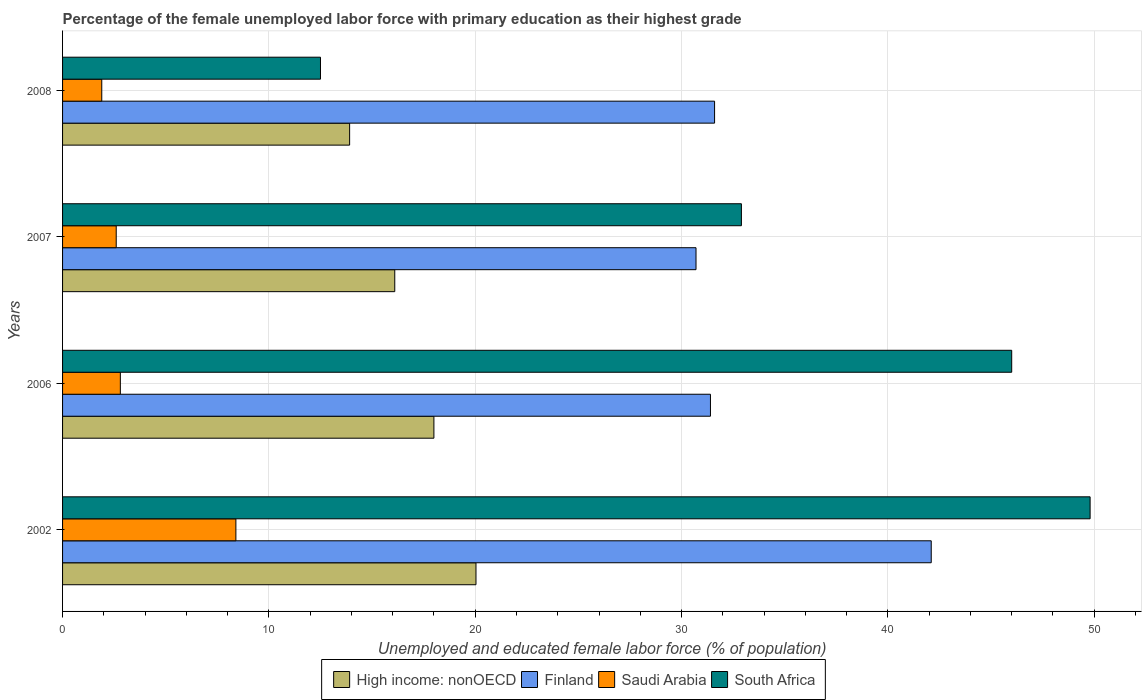How many groups of bars are there?
Ensure brevity in your answer.  4. What is the percentage of the unemployed female labor force with primary education in High income: nonOECD in 2008?
Offer a very short reply. 13.91. Across all years, what is the maximum percentage of the unemployed female labor force with primary education in South Africa?
Ensure brevity in your answer.  49.8. Across all years, what is the minimum percentage of the unemployed female labor force with primary education in South Africa?
Offer a terse response. 12.5. In which year was the percentage of the unemployed female labor force with primary education in South Africa minimum?
Your answer should be compact. 2008. What is the total percentage of the unemployed female labor force with primary education in Saudi Arabia in the graph?
Give a very brief answer. 15.7. What is the difference between the percentage of the unemployed female labor force with primary education in Saudi Arabia in 2006 and that in 2008?
Make the answer very short. 0.9. What is the difference between the percentage of the unemployed female labor force with primary education in Saudi Arabia in 2008 and the percentage of the unemployed female labor force with primary education in High income: nonOECD in 2007?
Your answer should be very brief. -14.2. What is the average percentage of the unemployed female labor force with primary education in Saudi Arabia per year?
Ensure brevity in your answer.  3.92. In the year 2007, what is the difference between the percentage of the unemployed female labor force with primary education in South Africa and percentage of the unemployed female labor force with primary education in Finland?
Offer a very short reply. 2.2. What is the ratio of the percentage of the unemployed female labor force with primary education in High income: nonOECD in 2002 to that in 2007?
Give a very brief answer. 1.24. Is the difference between the percentage of the unemployed female labor force with primary education in South Africa in 2006 and 2008 greater than the difference between the percentage of the unemployed female labor force with primary education in Finland in 2006 and 2008?
Make the answer very short. Yes. What is the difference between the highest and the second highest percentage of the unemployed female labor force with primary education in South Africa?
Offer a terse response. 3.8. What is the difference between the highest and the lowest percentage of the unemployed female labor force with primary education in South Africa?
Offer a very short reply. 37.3. In how many years, is the percentage of the unemployed female labor force with primary education in South Africa greater than the average percentage of the unemployed female labor force with primary education in South Africa taken over all years?
Provide a succinct answer. 2. Is it the case that in every year, the sum of the percentage of the unemployed female labor force with primary education in South Africa and percentage of the unemployed female labor force with primary education in Finland is greater than the sum of percentage of the unemployed female labor force with primary education in Saudi Arabia and percentage of the unemployed female labor force with primary education in High income: nonOECD?
Your answer should be compact. No. What does the 4th bar from the top in 2006 represents?
Give a very brief answer. High income: nonOECD. What does the 1st bar from the bottom in 2002 represents?
Ensure brevity in your answer.  High income: nonOECD. Is it the case that in every year, the sum of the percentage of the unemployed female labor force with primary education in High income: nonOECD and percentage of the unemployed female labor force with primary education in Saudi Arabia is greater than the percentage of the unemployed female labor force with primary education in Finland?
Keep it short and to the point. No. How many years are there in the graph?
Offer a very short reply. 4. What is the difference between two consecutive major ticks on the X-axis?
Offer a terse response. 10. Does the graph contain any zero values?
Your answer should be compact. No. What is the title of the graph?
Offer a very short reply. Percentage of the female unemployed labor force with primary education as their highest grade. Does "Canada" appear as one of the legend labels in the graph?
Your answer should be compact. No. What is the label or title of the X-axis?
Ensure brevity in your answer.  Unemployed and educated female labor force (% of population). What is the Unemployed and educated female labor force (% of population) of High income: nonOECD in 2002?
Give a very brief answer. 20.04. What is the Unemployed and educated female labor force (% of population) of Finland in 2002?
Provide a succinct answer. 42.1. What is the Unemployed and educated female labor force (% of population) in Saudi Arabia in 2002?
Give a very brief answer. 8.4. What is the Unemployed and educated female labor force (% of population) in South Africa in 2002?
Give a very brief answer. 49.8. What is the Unemployed and educated female labor force (% of population) in High income: nonOECD in 2006?
Offer a very short reply. 18. What is the Unemployed and educated female labor force (% of population) of Finland in 2006?
Offer a terse response. 31.4. What is the Unemployed and educated female labor force (% of population) in Saudi Arabia in 2006?
Offer a very short reply. 2.8. What is the Unemployed and educated female labor force (% of population) in South Africa in 2006?
Offer a terse response. 46. What is the Unemployed and educated female labor force (% of population) in High income: nonOECD in 2007?
Offer a terse response. 16.1. What is the Unemployed and educated female labor force (% of population) of Finland in 2007?
Offer a terse response. 30.7. What is the Unemployed and educated female labor force (% of population) of Saudi Arabia in 2007?
Offer a very short reply. 2.6. What is the Unemployed and educated female labor force (% of population) of South Africa in 2007?
Your answer should be very brief. 32.9. What is the Unemployed and educated female labor force (% of population) of High income: nonOECD in 2008?
Keep it short and to the point. 13.91. What is the Unemployed and educated female labor force (% of population) of Finland in 2008?
Your response must be concise. 31.6. What is the Unemployed and educated female labor force (% of population) of Saudi Arabia in 2008?
Make the answer very short. 1.9. Across all years, what is the maximum Unemployed and educated female labor force (% of population) of High income: nonOECD?
Give a very brief answer. 20.04. Across all years, what is the maximum Unemployed and educated female labor force (% of population) of Finland?
Give a very brief answer. 42.1. Across all years, what is the maximum Unemployed and educated female labor force (% of population) of Saudi Arabia?
Ensure brevity in your answer.  8.4. Across all years, what is the maximum Unemployed and educated female labor force (% of population) in South Africa?
Give a very brief answer. 49.8. Across all years, what is the minimum Unemployed and educated female labor force (% of population) of High income: nonOECD?
Your response must be concise. 13.91. Across all years, what is the minimum Unemployed and educated female labor force (% of population) in Finland?
Your answer should be compact. 30.7. Across all years, what is the minimum Unemployed and educated female labor force (% of population) of Saudi Arabia?
Offer a terse response. 1.9. What is the total Unemployed and educated female labor force (% of population) of High income: nonOECD in the graph?
Your answer should be compact. 68.05. What is the total Unemployed and educated female labor force (% of population) in Finland in the graph?
Your answer should be very brief. 135.8. What is the total Unemployed and educated female labor force (% of population) in South Africa in the graph?
Ensure brevity in your answer.  141.2. What is the difference between the Unemployed and educated female labor force (% of population) in High income: nonOECD in 2002 and that in 2006?
Your answer should be very brief. 2.04. What is the difference between the Unemployed and educated female labor force (% of population) in Finland in 2002 and that in 2006?
Ensure brevity in your answer.  10.7. What is the difference between the Unemployed and educated female labor force (% of population) of Saudi Arabia in 2002 and that in 2006?
Offer a very short reply. 5.6. What is the difference between the Unemployed and educated female labor force (% of population) in High income: nonOECD in 2002 and that in 2007?
Offer a terse response. 3.94. What is the difference between the Unemployed and educated female labor force (% of population) of Finland in 2002 and that in 2007?
Offer a terse response. 11.4. What is the difference between the Unemployed and educated female labor force (% of population) in High income: nonOECD in 2002 and that in 2008?
Keep it short and to the point. 6.12. What is the difference between the Unemployed and educated female labor force (% of population) of Saudi Arabia in 2002 and that in 2008?
Keep it short and to the point. 6.5. What is the difference between the Unemployed and educated female labor force (% of population) in South Africa in 2002 and that in 2008?
Provide a succinct answer. 37.3. What is the difference between the Unemployed and educated female labor force (% of population) in High income: nonOECD in 2006 and that in 2007?
Your response must be concise. 1.9. What is the difference between the Unemployed and educated female labor force (% of population) in Saudi Arabia in 2006 and that in 2007?
Offer a terse response. 0.2. What is the difference between the Unemployed and educated female labor force (% of population) in South Africa in 2006 and that in 2007?
Provide a succinct answer. 13.1. What is the difference between the Unemployed and educated female labor force (% of population) of High income: nonOECD in 2006 and that in 2008?
Offer a very short reply. 4.09. What is the difference between the Unemployed and educated female labor force (% of population) of Finland in 2006 and that in 2008?
Ensure brevity in your answer.  -0.2. What is the difference between the Unemployed and educated female labor force (% of population) in Saudi Arabia in 2006 and that in 2008?
Your answer should be very brief. 0.9. What is the difference between the Unemployed and educated female labor force (% of population) of South Africa in 2006 and that in 2008?
Offer a terse response. 33.5. What is the difference between the Unemployed and educated female labor force (% of population) in High income: nonOECD in 2007 and that in 2008?
Offer a very short reply. 2.19. What is the difference between the Unemployed and educated female labor force (% of population) of South Africa in 2007 and that in 2008?
Provide a short and direct response. 20.4. What is the difference between the Unemployed and educated female labor force (% of population) in High income: nonOECD in 2002 and the Unemployed and educated female labor force (% of population) in Finland in 2006?
Provide a short and direct response. -11.36. What is the difference between the Unemployed and educated female labor force (% of population) of High income: nonOECD in 2002 and the Unemployed and educated female labor force (% of population) of Saudi Arabia in 2006?
Give a very brief answer. 17.24. What is the difference between the Unemployed and educated female labor force (% of population) in High income: nonOECD in 2002 and the Unemployed and educated female labor force (% of population) in South Africa in 2006?
Offer a very short reply. -25.96. What is the difference between the Unemployed and educated female labor force (% of population) in Finland in 2002 and the Unemployed and educated female labor force (% of population) in Saudi Arabia in 2006?
Ensure brevity in your answer.  39.3. What is the difference between the Unemployed and educated female labor force (% of population) of Finland in 2002 and the Unemployed and educated female labor force (% of population) of South Africa in 2006?
Your answer should be compact. -3.9. What is the difference between the Unemployed and educated female labor force (% of population) in Saudi Arabia in 2002 and the Unemployed and educated female labor force (% of population) in South Africa in 2006?
Your response must be concise. -37.6. What is the difference between the Unemployed and educated female labor force (% of population) in High income: nonOECD in 2002 and the Unemployed and educated female labor force (% of population) in Finland in 2007?
Your response must be concise. -10.66. What is the difference between the Unemployed and educated female labor force (% of population) in High income: nonOECD in 2002 and the Unemployed and educated female labor force (% of population) in Saudi Arabia in 2007?
Offer a very short reply. 17.44. What is the difference between the Unemployed and educated female labor force (% of population) of High income: nonOECD in 2002 and the Unemployed and educated female labor force (% of population) of South Africa in 2007?
Keep it short and to the point. -12.86. What is the difference between the Unemployed and educated female labor force (% of population) in Finland in 2002 and the Unemployed and educated female labor force (% of population) in Saudi Arabia in 2007?
Keep it short and to the point. 39.5. What is the difference between the Unemployed and educated female labor force (% of population) of Finland in 2002 and the Unemployed and educated female labor force (% of population) of South Africa in 2007?
Offer a terse response. 9.2. What is the difference between the Unemployed and educated female labor force (% of population) of Saudi Arabia in 2002 and the Unemployed and educated female labor force (% of population) of South Africa in 2007?
Your answer should be compact. -24.5. What is the difference between the Unemployed and educated female labor force (% of population) in High income: nonOECD in 2002 and the Unemployed and educated female labor force (% of population) in Finland in 2008?
Ensure brevity in your answer.  -11.56. What is the difference between the Unemployed and educated female labor force (% of population) of High income: nonOECD in 2002 and the Unemployed and educated female labor force (% of population) of Saudi Arabia in 2008?
Give a very brief answer. 18.14. What is the difference between the Unemployed and educated female labor force (% of population) in High income: nonOECD in 2002 and the Unemployed and educated female labor force (% of population) in South Africa in 2008?
Your response must be concise. 7.54. What is the difference between the Unemployed and educated female labor force (% of population) in Finland in 2002 and the Unemployed and educated female labor force (% of population) in Saudi Arabia in 2008?
Make the answer very short. 40.2. What is the difference between the Unemployed and educated female labor force (% of population) of Finland in 2002 and the Unemployed and educated female labor force (% of population) of South Africa in 2008?
Give a very brief answer. 29.6. What is the difference between the Unemployed and educated female labor force (% of population) in High income: nonOECD in 2006 and the Unemployed and educated female labor force (% of population) in Finland in 2007?
Ensure brevity in your answer.  -12.7. What is the difference between the Unemployed and educated female labor force (% of population) of High income: nonOECD in 2006 and the Unemployed and educated female labor force (% of population) of Saudi Arabia in 2007?
Keep it short and to the point. 15.4. What is the difference between the Unemployed and educated female labor force (% of population) in High income: nonOECD in 2006 and the Unemployed and educated female labor force (% of population) in South Africa in 2007?
Make the answer very short. -14.9. What is the difference between the Unemployed and educated female labor force (% of population) of Finland in 2006 and the Unemployed and educated female labor force (% of population) of Saudi Arabia in 2007?
Your answer should be compact. 28.8. What is the difference between the Unemployed and educated female labor force (% of population) of Saudi Arabia in 2006 and the Unemployed and educated female labor force (% of population) of South Africa in 2007?
Your answer should be compact. -30.1. What is the difference between the Unemployed and educated female labor force (% of population) in High income: nonOECD in 2006 and the Unemployed and educated female labor force (% of population) in Finland in 2008?
Your answer should be very brief. -13.6. What is the difference between the Unemployed and educated female labor force (% of population) in High income: nonOECD in 2006 and the Unemployed and educated female labor force (% of population) in Saudi Arabia in 2008?
Offer a very short reply. 16.1. What is the difference between the Unemployed and educated female labor force (% of population) of High income: nonOECD in 2006 and the Unemployed and educated female labor force (% of population) of South Africa in 2008?
Your answer should be compact. 5.5. What is the difference between the Unemployed and educated female labor force (% of population) in Finland in 2006 and the Unemployed and educated female labor force (% of population) in Saudi Arabia in 2008?
Offer a very short reply. 29.5. What is the difference between the Unemployed and educated female labor force (% of population) of Finland in 2006 and the Unemployed and educated female labor force (% of population) of South Africa in 2008?
Keep it short and to the point. 18.9. What is the difference between the Unemployed and educated female labor force (% of population) in Saudi Arabia in 2006 and the Unemployed and educated female labor force (% of population) in South Africa in 2008?
Offer a very short reply. -9.7. What is the difference between the Unemployed and educated female labor force (% of population) in High income: nonOECD in 2007 and the Unemployed and educated female labor force (% of population) in Finland in 2008?
Give a very brief answer. -15.5. What is the difference between the Unemployed and educated female labor force (% of population) of High income: nonOECD in 2007 and the Unemployed and educated female labor force (% of population) of Saudi Arabia in 2008?
Ensure brevity in your answer.  14.2. What is the difference between the Unemployed and educated female labor force (% of population) of High income: nonOECD in 2007 and the Unemployed and educated female labor force (% of population) of South Africa in 2008?
Provide a succinct answer. 3.6. What is the difference between the Unemployed and educated female labor force (% of population) in Finland in 2007 and the Unemployed and educated female labor force (% of population) in Saudi Arabia in 2008?
Your response must be concise. 28.8. What is the average Unemployed and educated female labor force (% of population) in High income: nonOECD per year?
Give a very brief answer. 17.01. What is the average Unemployed and educated female labor force (% of population) of Finland per year?
Your answer should be very brief. 33.95. What is the average Unemployed and educated female labor force (% of population) of Saudi Arabia per year?
Your answer should be compact. 3.92. What is the average Unemployed and educated female labor force (% of population) in South Africa per year?
Offer a terse response. 35.3. In the year 2002, what is the difference between the Unemployed and educated female labor force (% of population) in High income: nonOECD and Unemployed and educated female labor force (% of population) in Finland?
Your answer should be very brief. -22.06. In the year 2002, what is the difference between the Unemployed and educated female labor force (% of population) of High income: nonOECD and Unemployed and educated female labor force (% of population) of Saudi Arabia?
Offer a terse response. 11.64. In the year 2002, what is the difference between the Unemployed and educated female labor force (% of population) in High income: nonOECD and Unemployed and educated female labor force (% of population) in South Africa?
Offer a very short reply. -29.76. In the year 2002, what is the difference between the Unemployed and educated female labor force (% of population) of Finland and Unemployed and educated female labor force (% of population) of Saudi Arabia?
Your answer should be compact. 33.7. In the year 2002, what is the difference between the Unemployed and educated female labor force (% of population) in Saudi Arabia and Unemployed and educated female labor force (% of population) in South Africa?
Make the answer very short. -41.4. In the year 2006, what is the difference between the Unemployed and educated female labor force (% of population) in High income: nonOECD and Unemployed and educated female labor force (% of population) in Finland?
Your answer should be compact. -13.4. In the year 2006, what is the difference between the Unemployed and educated female labor force (% of population) in High income: nonOECD and Unemployed and educated female labor force (% of population) in Saudi Arabia?
Your answer should be very brief. 15.2. In the year 2006, what is the difference between the Unemployed and educated female labor force (% of population) of High income: nonOECD and Unemployed and educated female labor force (% of population) of South Africa?
Ensure brevity in your answer.  -28. In the year 2006, what is the difference between the Unemployed and educated female labor force (% of population) in Finland and Unemployed and educated female labor force (% of population) in Saudi Arabia?
Offer a very short reply. 28.6. In the year 2006, what is the difference between the Unemployed and educated female labor force (% of population) in Finland and Unemployed and educated female labor force (% of population) in South Africa?
Keep it short and to the point. -14.6. In the year 2006, what is the difference between the Unemployed and educated female labor force (% of population) in Saudi Arabia and Unemployed and educated female labor force (% of population) in South Africa?
Your response must be concise. -43.2. In the year 2007, what is the difference between the Unemployed and educated female labor force (% of population) in High income: nonOECD and Unemployed and educated female labor force (% of population) in Finland?
Offer a very short reply. -14.6. In the year 2007, what is the difference between the Unemployed and educated female labor force (% of population) in High income: nonOECD and Unemployed and educated female labor force (% of population) in Saudi Arabia?
Offer a terse response. 13.5. In the year 2007, what is the difference between the Unemployed and educated female labor force (% of population) in High income: nonOECD and Unemployed and educated female labor force (% of population) in South Africa?
Make the answer very short. -16.8. In the year 2007, what is the difference between the Unemployed and educated female labor force (% of population) of Finland and Unemployed and educated female labor force (% of population) of Saudi Arabia?
Offer a very short reply. 28.1. In the year 2007, what is the difference between the Unemployed and educated female labor force (% of population) of Finland and Unemployed and educated female labor force (% of population) of South Africa?
Ensure brevity in your answer.  -2.2. In the year 2007, what is the difference between the Unemployed and educated female labor force (% of population) of Saudi Arabia and Unemployed and educated female labor force (% of population) of South Africa?
Ensure brevity in your answer.  -30.3. In the year 2008, what is the difference between the Unemployed and educated female labor force (% of population) in High income: nonOECD and Unemployed and educated female labor force (% of population) in Finland?
Your response must be concise. -17.69. In the year 2008, what is the difference between the Unemployed and educated female labor force (% of population) in High income: nonOECD and Unemployed and educated female labor force (% of population) in Saudi Arabia?
Your answer should be compact. 12.01. In the year 2008, what is the difference between the Unemployed and educated female labor force (% of population) in High income: nonOECD and Unemployed and educated female labor force (% of population) in South Africa?
Keep it short and to the point. 1.41. In the year 2008, what is the difference between the Unemployed and educated female labor force (% of population) of Finland and Unemployed and educated female labor force (% of population) of Saudi Arabia?
Make the answer very short. 29.7. What is the ratio of the Unemployed and educated female labor force (% of population) in High income: nonOECD in 2002 to that in 2006?
Give a very brief answer. 1.11. What is the ratio of the Unemployed and educated female labor force (% of population) of Finland in 2002 to that in 2006?
Your response must be concise. 1.34. What is the ratio of the Unemployed and educated female labor force (% of population) of South Africa in 2002 to that in 2006?
Offer a very short reply. 1.08. What is the ratio of the Unemployed and educated female labor force (% of population) in High income: nonOECD in 2002 to that in 2007?
Make the answer very short. 1.24. What is the ratio of the Unemployed and educated female labor force (% of population) in Finland in 2002 to that in 2007?
Offer a terse response. 1.37. What is the ratio of the Unemployed and educated female labor force (% of population) in Saudi Arabia in 2002 to that in 2007?
Your response must be concise. 3.23. What is the ratio of the Unemployed and educated female labor force (% of population) of South Africa in 2002 to that in 2007?
Provide a succinct answer. 1.51. What is the ratio of the Unemployed and educated female labor force (% of population) of High income: nonOECD in 2002 to that in 2008?
Offer a terse response. 1.44. What is the ratio of the Unemployed and educated female labor force (% of population) of Finland in 2002 to that in 2008?
Make the answer very short. 1.33. What is the ratio of the Unemployed and educated female labor force (% of population) of Saudi Arabia in 2002 to that in 2008?
Provide a succinct answer. 4.42. What is the ratio of the Unemployed and educated female labor force (% of population) of South Africa in 2002 to that in 2008?
Give a very brief answer. 3.98. What is the ratio of the Unemployed and educated female labor force (% of population) in High income: nonOECD in 2006 to that in 2007?
Give a very brief answer. 1.12. What is the ratio of the Unemployed and educated female labor force (% of population) of Finland in 2006 to that in 2007?
Your response must be concise. 1.02. What is the ratio of the Unemployed and educated female labor force (% of population) of South Africa in 2006 to that in 2007?
Make the answer very short. 1.4. What is the ratio of the Unemployed and educated female labor force (% of population) in High income: nonOECD in 2006 to that in 2008?
Keep it short and to the point. 1.29. What is the ratio of the Unemployed and educated female labor force (% of population) of Finland in 2006 to that in 2008?
Ensure brevity in your answer.  0.99. What is the ratio of the Unemployed and educated female labor force (% of population) in Saudi Arabia in 2006 to that in 2008?
Provide a succinct answer. 1.47. What is the ratio of the Unemployed and educated female labor force (% of population) in South Africa in 2006 to that in 2008?
Offer a terse response. 3.68. What is the ratio of the Unemployed and educated female labor force (% of population) in High income: nonOECD in 2007 to that in 2008?
Keep it short and to the point. 1.16. What is the ratio of the Unemployed and educated female labor force (% of population) in Finland in 2007 to that in 2008?
Your answer should be compact. 0.97. What is the ratio of the Unemployed and educated female labor force (% of population) in Saudi Arabia in 2007 to that in 2008?
Offer a very short reply. 1.37. What is the ratio of the Unemployed and educated female labor force (% of population) of South Africa in 2007 to that in 2008?
Offer a terse response. 2.63. What is the difference between the highest and the second highest Unemployed and educated female labor force (% of population) of High income: nonOECD?
Make the answer very short. 2.04. What is the difference between the highest and the second highest Unemployed and educated female labor force (% of population) in Saudi Arabia?
Keep it short and to the point. 5.6. What is the difference between the highest and the lowest Unemployed and educated female labor force (% of population) in High income: nonOECD?
Your response must be concise. 6.12. What is the difference between the highest and the lowest Unemployed and educated female labor force (% of population) of South Africa?
Your response must be concise. 37.3. 